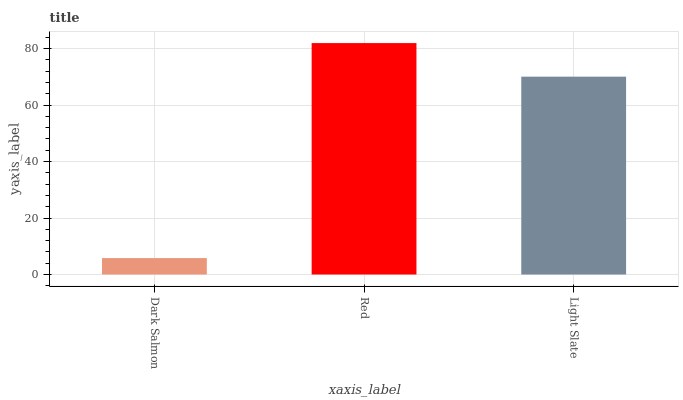Is Dark Salmon the minimum?
Answer yes or no. Yes. Is Red the maximum?
Answer yes or no. Yes. Is Light Slate the minimum?
Answer yes or no. No. Is Light Slate the maximum?
Answer yes or no. No. Is Red greater than Light Slate?
Answer yes or no. Yes. Is Light Slate less than Red?
Answer yes or no. Yes. Is Light Slate greater than Red?
Answer yes or no. No. Is Red less than Light Slate?
Answer yes or no. No. Is Light Slate the high median?
Answer yes or no. Yes. Is Light Slate the low median?
Answer yes or no. Yes. Is Dark Salmon the high median?
Answer yes or no. No. Is Dark Salmon the low median?
Answer yes or no. No. 